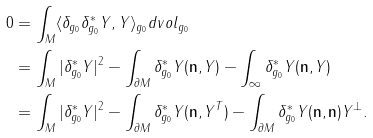<formula> <loc_0><loc_0><loc_500><loc_500>0 & = \int _ { M } \langle \delta _ { g _ { 0 } } \delta _ { g _ { 0 } } ^ { * } Y , Y \rangle _ { g _ { 0 } } d v o l _ { g _ { 0 } } \\ & = \int _ { M } | \delta _ { g _ { 0 } } ^ { * } Y | ^ { 2 } - \int _ { \partial M } \delta _ { g _ { 0 } } ^ { * } Y ( \mathbf n , Y ) - \int _ { \infty } \delta ^ { * } _ { g _ { 0 } } Y ( \mathbf n , Y ) \\ & = \int _ { M } | \delta _ { g _ { 0 } } ^ { * } Y | ^ { 2 } - \int _ { \partial M } \delta _ { g _ { 0 } } ^ { * } Y ( \mathbf n , Y ^ { T } ) - \int _ { \partial M } \delta _ { g _ { 0 } } ^ { * } Y ( \mathbf n , \mathbf n ) Y ^ { \perp } .</formula> 